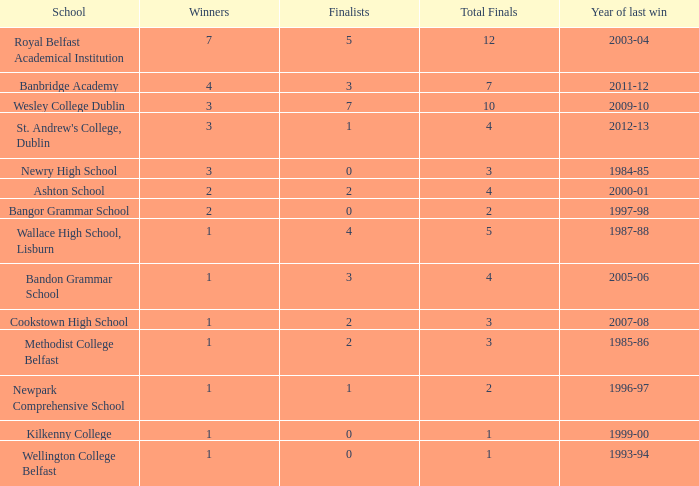What is the name of the school where the year of last win is 1985-86? Methodist College Belfast. 